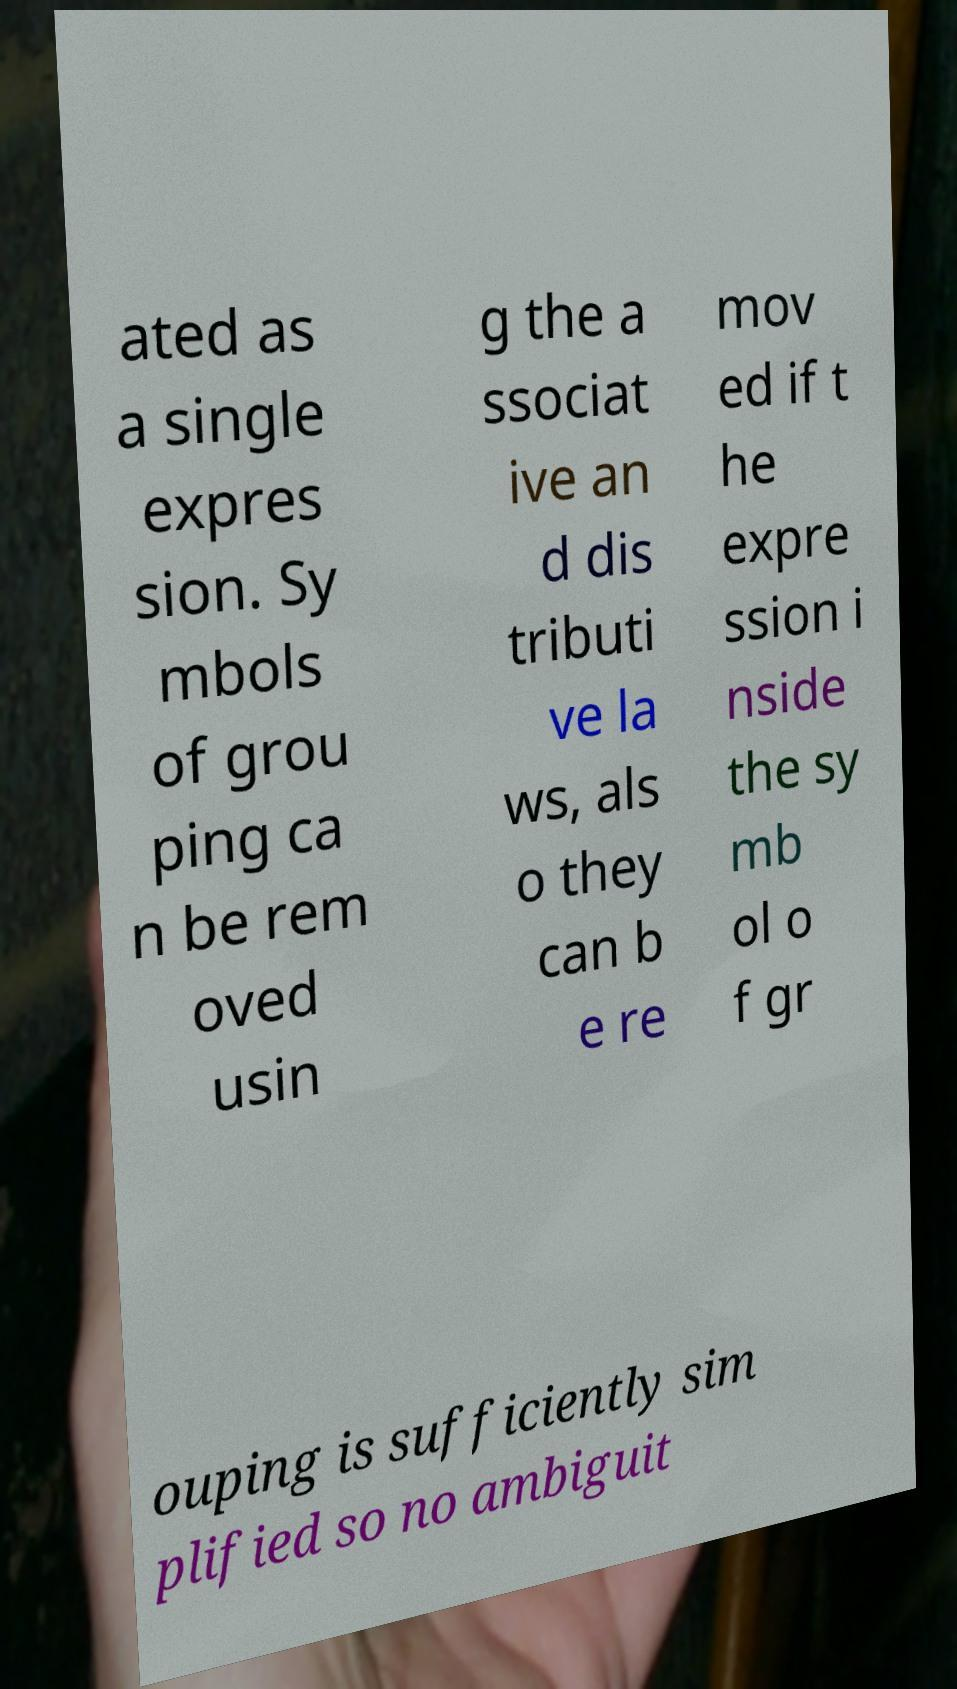Please read and relay the text visible in this image. What does it say? ated as a single expres sion. Sy mbols of grou ping ca n be rem oved usin g the a ssociat ive an d dis tributi ve la ws, als o they can b e re mov ed if t he expre ssion i nside the sy mb ol o f gr ouping is sufficiently sim plified so no ambiguit 